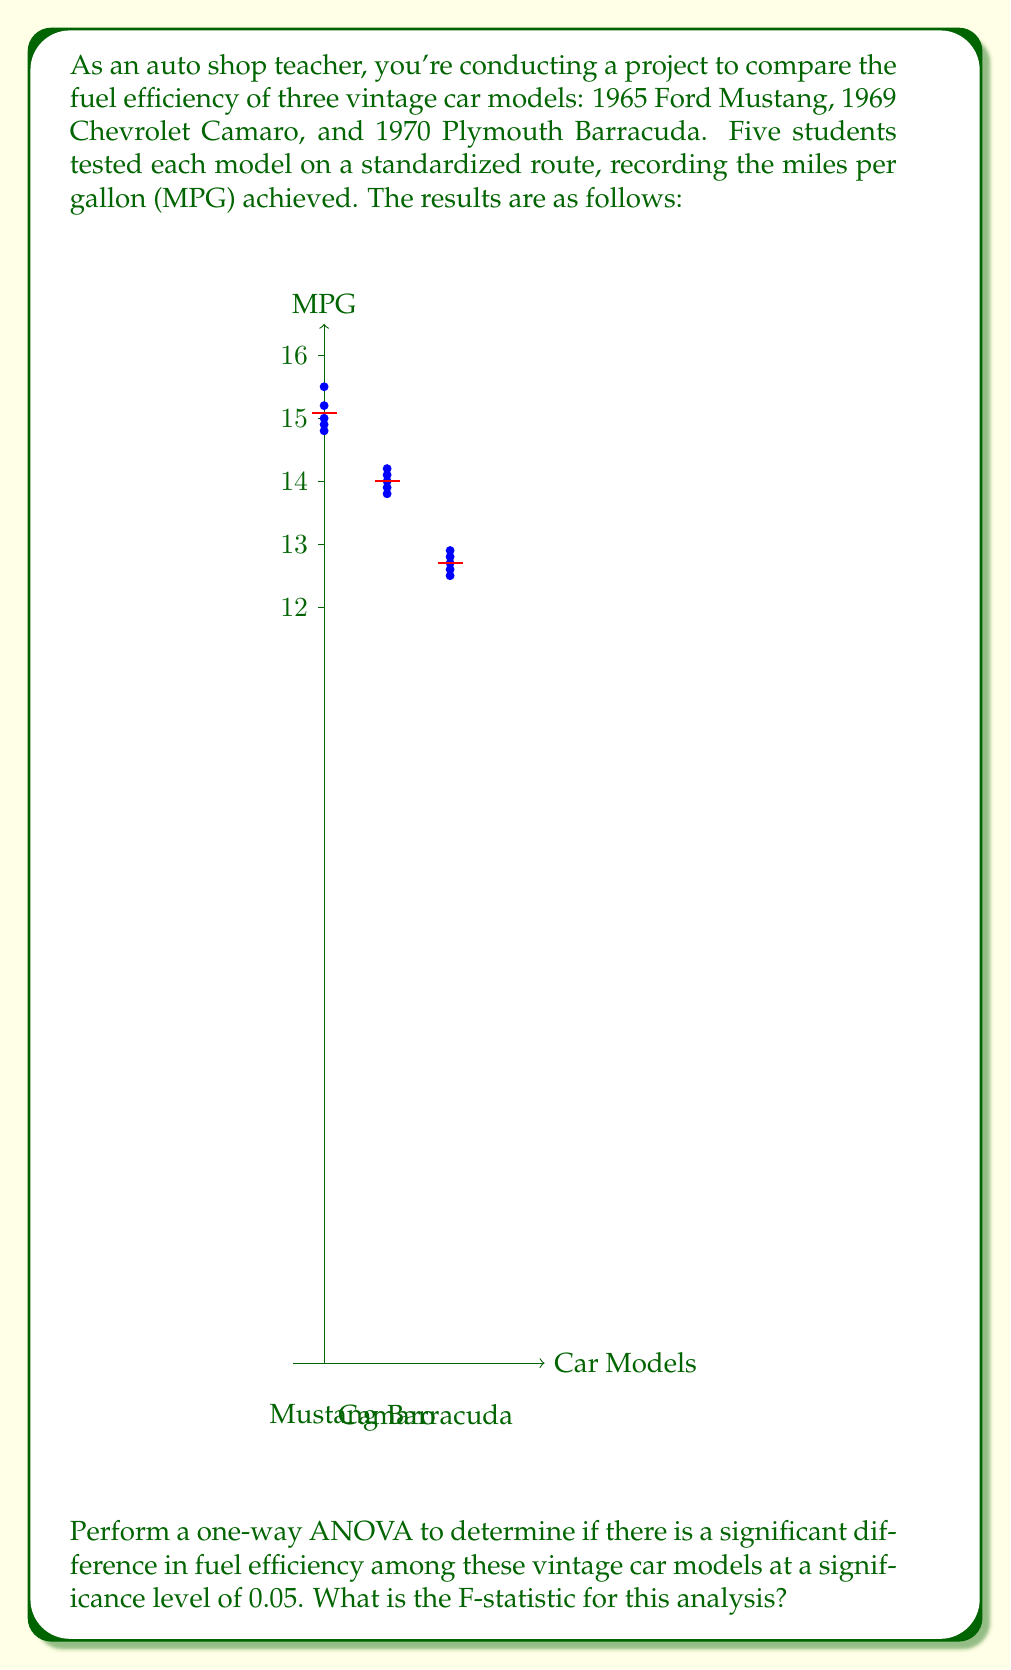Provide a solution to this math problem. To perform a one-way ANOVA, we'll follow these steps:

1) Calculate the overall mean:
   $$\bar{X} = \frac{15.2 + 14.8 + ... + 12.7}{15} = 13.86$$

2) Calculate the Sum of Squares Total (SST):
   $$SST = \sum_{i=1}^{3}\sum_{j=1}^{5}(X_{ij} - \bar{X})^2 = 24.9093$$

3) Calculate the Sum of Squares Between (SSB):
   $$SSB = 5\sum_{i=1}^{3}(\bar{X_i} - \bar{X})^2$$
   Where $\bar{X_i}$ are the group means:
   Mustang: 15.08, Camaro: 14.00, Barracuda: 12.70
   $$SSB = 5((15.08 - 13.86)^2 + (14.00 - 13.86)^2 + (12.70 - 13.86)^2) = 23.8013$$

4) Calculate the Sum of Squares Within (SSW):
   $$SSW = SST - SSB = 24.9093 - 23.8013 = 1.108$$

5) Calculate degrees of freedom:
   $$df_{between} = 3 - 1 = 2$$
   $$df_{within} = 15 - 3 = 12$$

6) Calculate Mean Square Between (MSB) and Mean Square Within (MSW):
   $$MSB = \frac{SSB}{df_{between}} = \frac{23.8013}{2} = 11.90065$$
   $$MSW = \frac{SSW}{df_{within}} = \frac{1.108}{12} = 0.09233$$

7) Calculate the F-statistic:
   $$F = \frac{MSB}{MSW} = \frac{11.90065}{0.09233} = 128.89$$

The F-statistic for this analysis is approximately 128.89.
Answer: $F = 128.89$ 